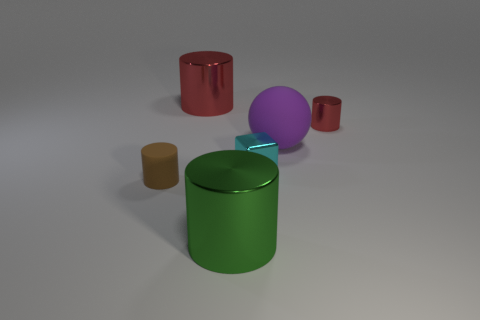Does the small red metal object have the same shape as the large red object?
Provide a short and direct response. Yes. There is a purple rubber sphere behind the brown matte cylinder; is it the same size as the red thing left of the purple matte ball?
Your response must be concise. Yes. What is the size of the thing that is on the right side of the green metal object and behind the ball?
Keep it short and to the point. Small. The other big metallic object that is the same shape as the big red metallic object is what color?
Provide a short and direct response. Green. Are there more small shiny objects that are on the right side of the large sphere than cyan shiny objects in front of the brown thing?
Your answer should be very brief. Yes. How many other objects are there of the same shape as the tiny red shiny thing?
Provide a short and direct response. 3. There is a purple thing that is to the right of the brown rubber thing; are there any big objects left of it?
Ensure brevity in your answer.  Yes. What number of blocks are there?
Keep it short and to the point. 1. There is a tiny metal cylinder; does it have the same color as the big cylinder that is behind the tiny brown cylinder?
Offer a terse response. Yes. Is the number of small metal blocks greater than the number of cyan metallic cylinders?
Your answer should be very brief. Yes. 